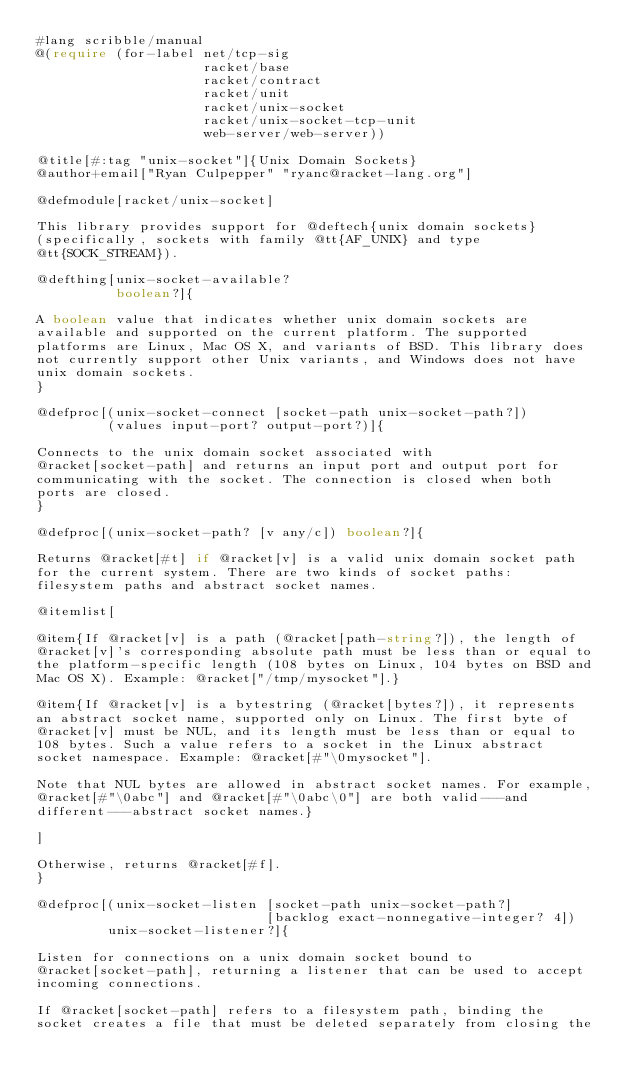<code> <loc_0><loc_0><loc_500><loc_500><_Racket_>#lang scribble/manual
@(require (for-label net/tcp-sig
                     racket/base
                     racket/contract
                     racket/unit
                     racket/unix-socket
                     racket/unix-socket-tcp-unit
                     web-server/web-server))

@title[#:tag "unix-socket"]{Unix Domain Sockets}
@author+email["Ryan Culpepper" "ryanc@racket-lang.org"]

@defmodule[racket/unix-socket]

This library provides support for @deftech{unix domain sockets}
(specifically, sockets with family @tt{AF_UNIX} and type
@tt{SOCK_STREAM}).

@defthing[unix-socket-available?
          boolean?]{

A boolean value that indicates whether unix domain sockets are
available and supported on the current platform. The supported
platforms are Linux, Mac OS X, and variants of BSD. This library does
not currently support other Unix variants, and Windows does not have
unix domain sockets.
}

@defproc[(unix-socket-connect [socket-path unix-socket-path?])
         (values input-port? output-port?)]{

Connects to the unix domain socket associated with
@racket[socket-path] and returns an input port and output port for
communicating with the socket. The connection is closed when both
ports are closed.
}

@defproc[(unix-socket-path? [v any/c]) boolean?]{

Returns @racket[#t] if @racket[v] is a valid unix domain socket path
for the current system. There are two kinds of socket paths:
filesystem paths and abstract socket names.

@itemlist[

@item{If @racket[v] is a path (@racket[path-string?]), the length of
@racket[v]'s corresponding absolute path must be less than or equal to
the platform-specific length (108 bytes on Linux, 104 bytes on BSD and
Mac OS X). Example: @racket["/tmp/mysocket"].}

@item{If @racket[v] is a bytestring (@racket[bytes?]), it represents
an abstract socket name, supported only on Linux. The first byte of
@racket[v] must be NUL, and its length must be less than or equal to
108 bytes. Such a value refers to a socket in the Linux abstract
socket namespace. Example: @racket[#"\0mysocket"].

Note that NUL bytes are allowed in abstract socket names. For example,
@racket[#"\0abc"] and @racket[#"\0abc\0"] are both valid---and
different---abstract socket names.}

]

Otherwise, returns @racket[#f].
}

@defproc[(unix-socket-listen [socket-path unix-socket-path?]
                             [backlog exact-nonnegative-integer? 4])
         unix-socket-listener?]{

Listen for connections on a unix domain socket bound to
@racket[socket-path], returning a listener that can be used to accept
incoming connections.

If @racket[socket-path] refers to a filesystem path, binding the
socket creates a file that must be deleted separately from closing the</code> 